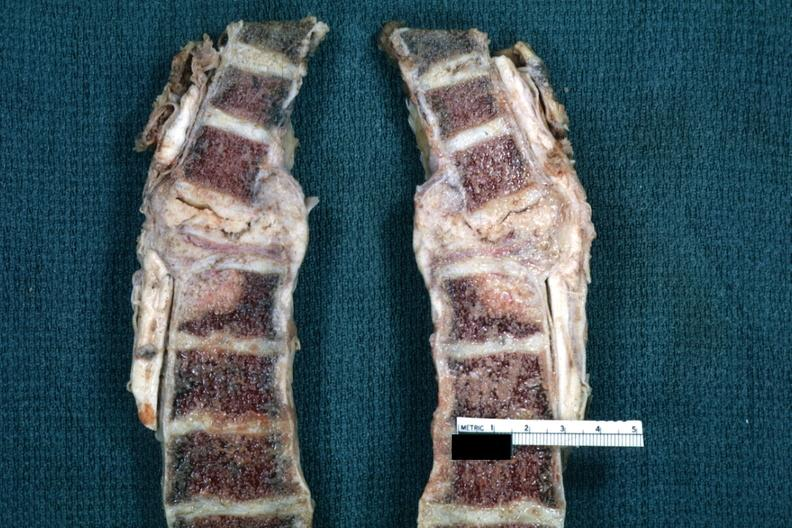what is present?
Answer the question using a single word or phrase. Joints 